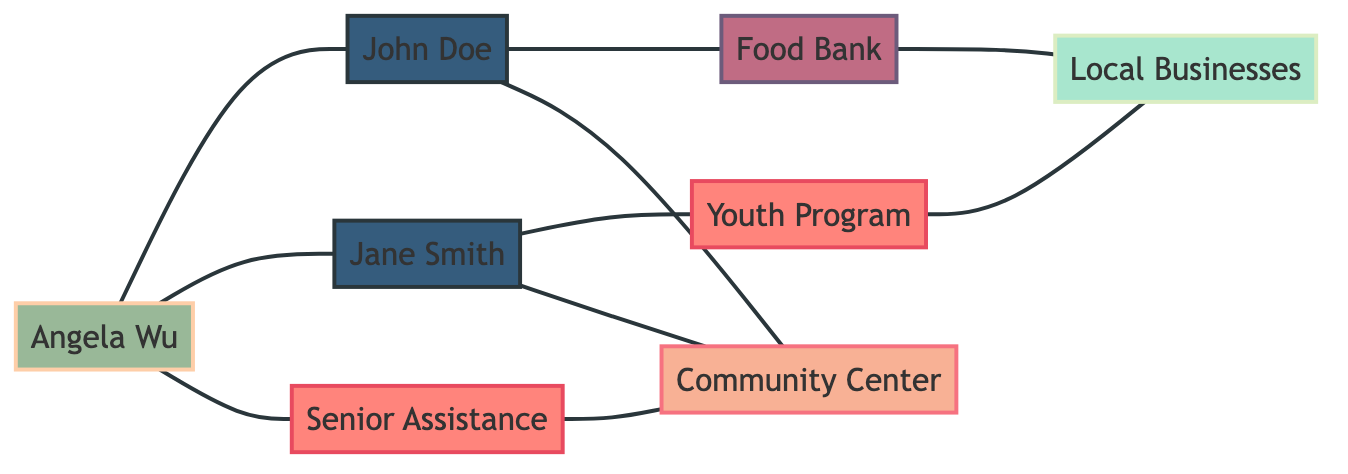What is the total number of nodes in the diagram? The nodes present in the diagram include: Community Center, Food Bank, John Doe, Jane Smith, Angela Wu, Youth Program, Senior Assistance, and Local Businesses. Counting these gives a total of 8 nodes.
Answer: 8 Who is the volunteer coordinator? The node identified as a "volunteer coordinator" in the diagram is Angela Wu.
Answer: Angela Wu Which node connects to both volunteers in the diagram? Both John Doe and Jane Smith connect to the node Angela Wu, indicating that she coordinates their activities. Following the edges from both volunteers leads to Angela Wu.
Answer: Angela Wu How many programs are represented in the graph? The nodes labeled as programs are Youth Program and Senior Assistance. Counting these reveals there are 2 programs in total.
Answer: 2 What services does John Doe provide support for? John Doe connects to the Food Bank and the Community Center, indicating his support for both of these services. The edges lead directly from John Doe to these two service nodes.
Answer: Food Bank, Community Center Which program collaborates with Local Businesses? The Youth Program node connects directly to Local Businesses, indicating collaboration. Tracing the edge from Youth Program to Local Businesses reveals this relationship.
Answer: Youth Program How many edges are connected to Angela Wu? Examining the connections to Angela Wu, we see she has edges connecting to John Doe, Jane Smith, and Senior Assistance, resulting in a total of 3 edges.
Answer: 3 Is there any connection between the Food Bank and Local Businesses? Yes, the diagram shows a direct edge between the Food Bank and Local Businesses, indicating a relationship or collaboration. Tracing the edge clearly shows this connection.
Answer: Yes What role does Jane Smith play in the organization? Jane Smith is labeled as a "volunteer" in the diagram, showcasing her role within the community volunteer organization. This is evident from the node type designation.
Answer: volunteer 